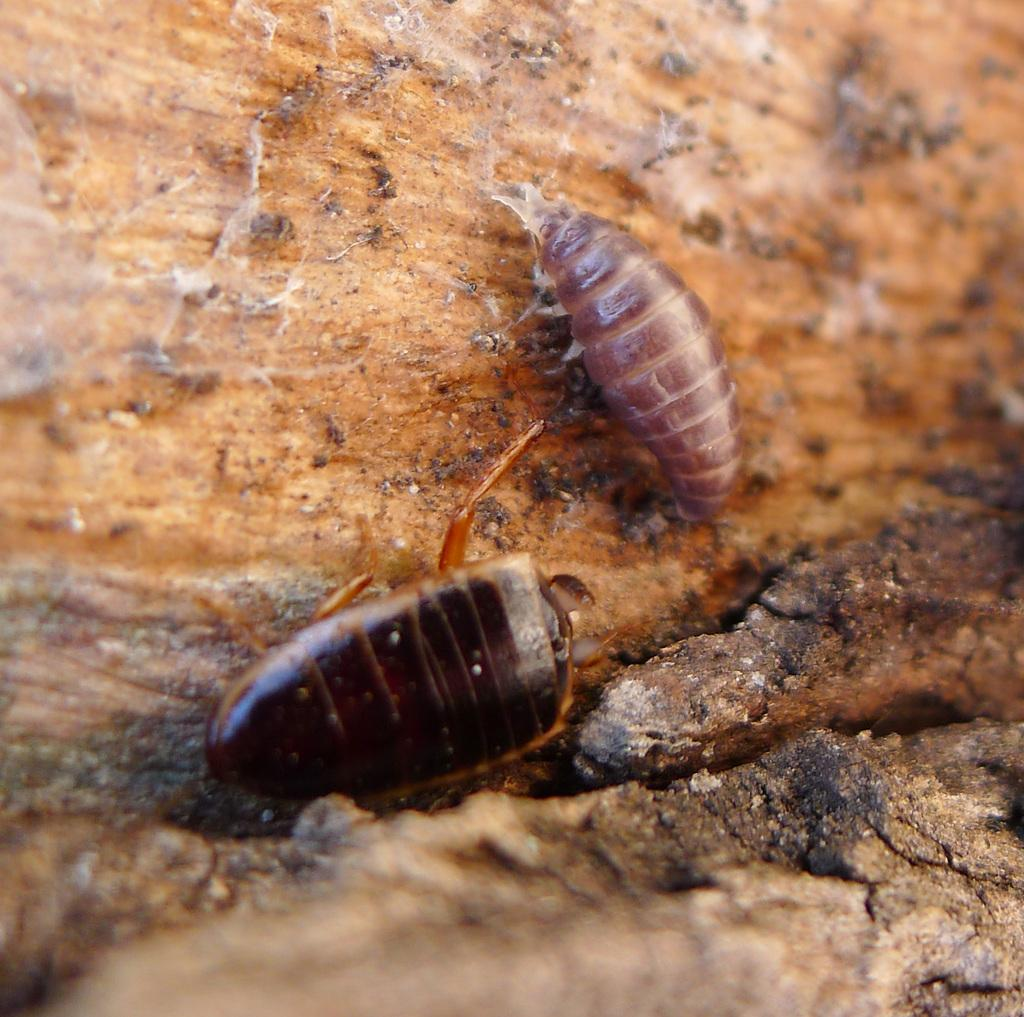How many insects can be seen in the image? There are two insects in the image. What is the color of the surface where the insects are located? The insects are on a brown color surface. What type of bridge can be seen in the image? There is no bridge present in the image; it features two insects on a brown color surface. Are the insects wearing masks in the image? There is no indication in the image that the insects are wearing masks. 